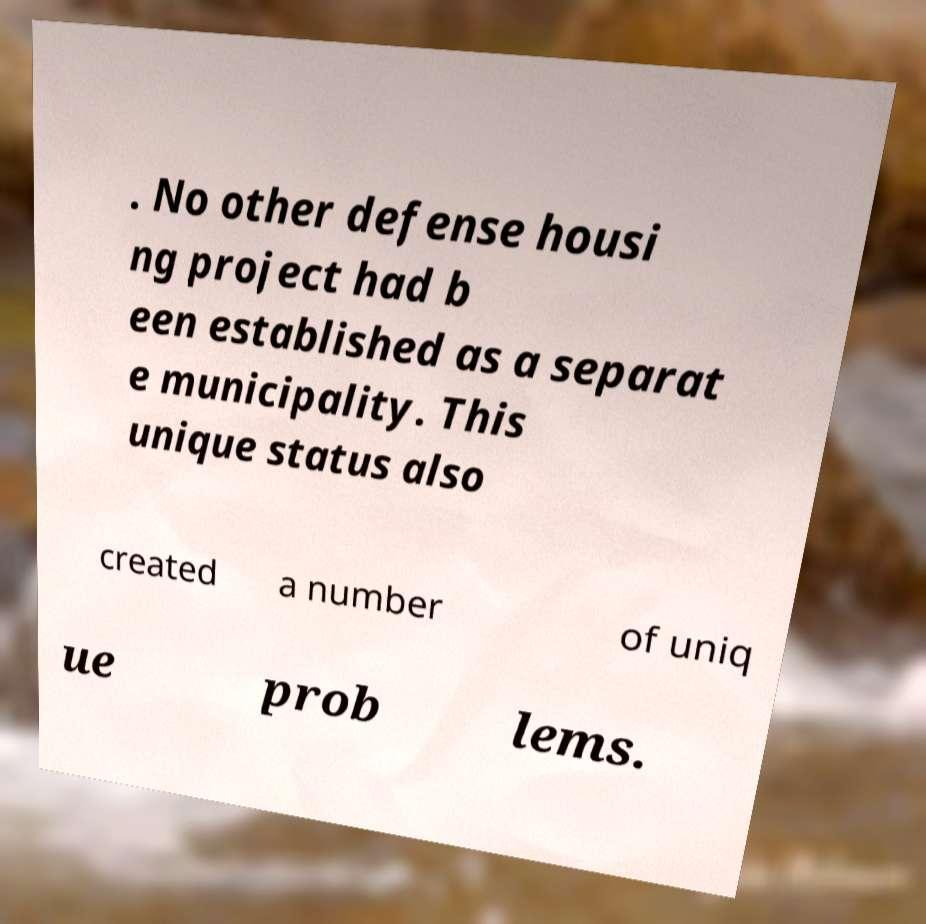There's text embedded in this image that I need extracted. Can you transcribe it verbatim? . No other defense housi ng project had b een established as a separat e municipality. This unique status also created a number of uniq ue prob lems. 